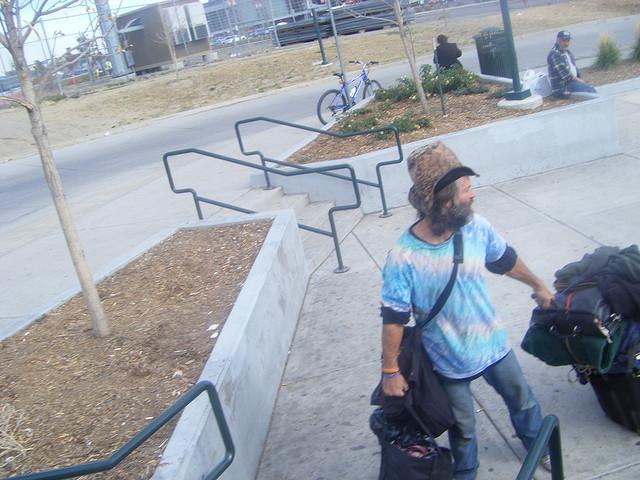How many people are in the picture?
Give a very brief answer. 3. How many holes on the side of the person's hat?
Give a very brief answer. 0. How many bicycles are there?
Give a very brief answer. 1. How many bags are sitting on the ground?
Give a very brief answer. 2. How many handbags are there?
Give a very brief answer. 3. How many people on motorcycles are facing this way?
Give a very brief answer. 0. 